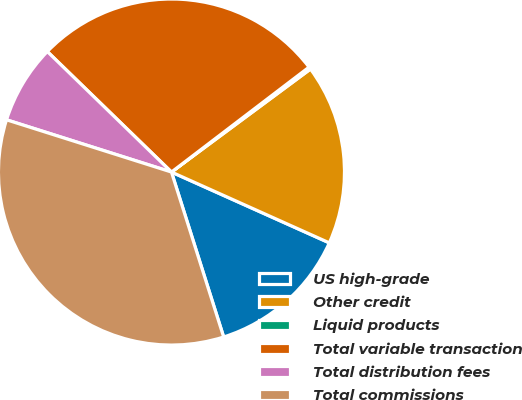Convert chart to OTSL. <chart><loc_0><loc_0><loc_500><loc_500><pie_chart><fcel>US high-grade<fcel>Other credit<fcel>Liquid products<fcel>Total variable transaction<fcel>Total distribution fees<fcel>Total commissions<nl><fcel>13.41%<fcel>16.86%<fcel>0.22%<fcel>27.37%<fcel>7.38%<fcel>34.76%<nl></chart> 